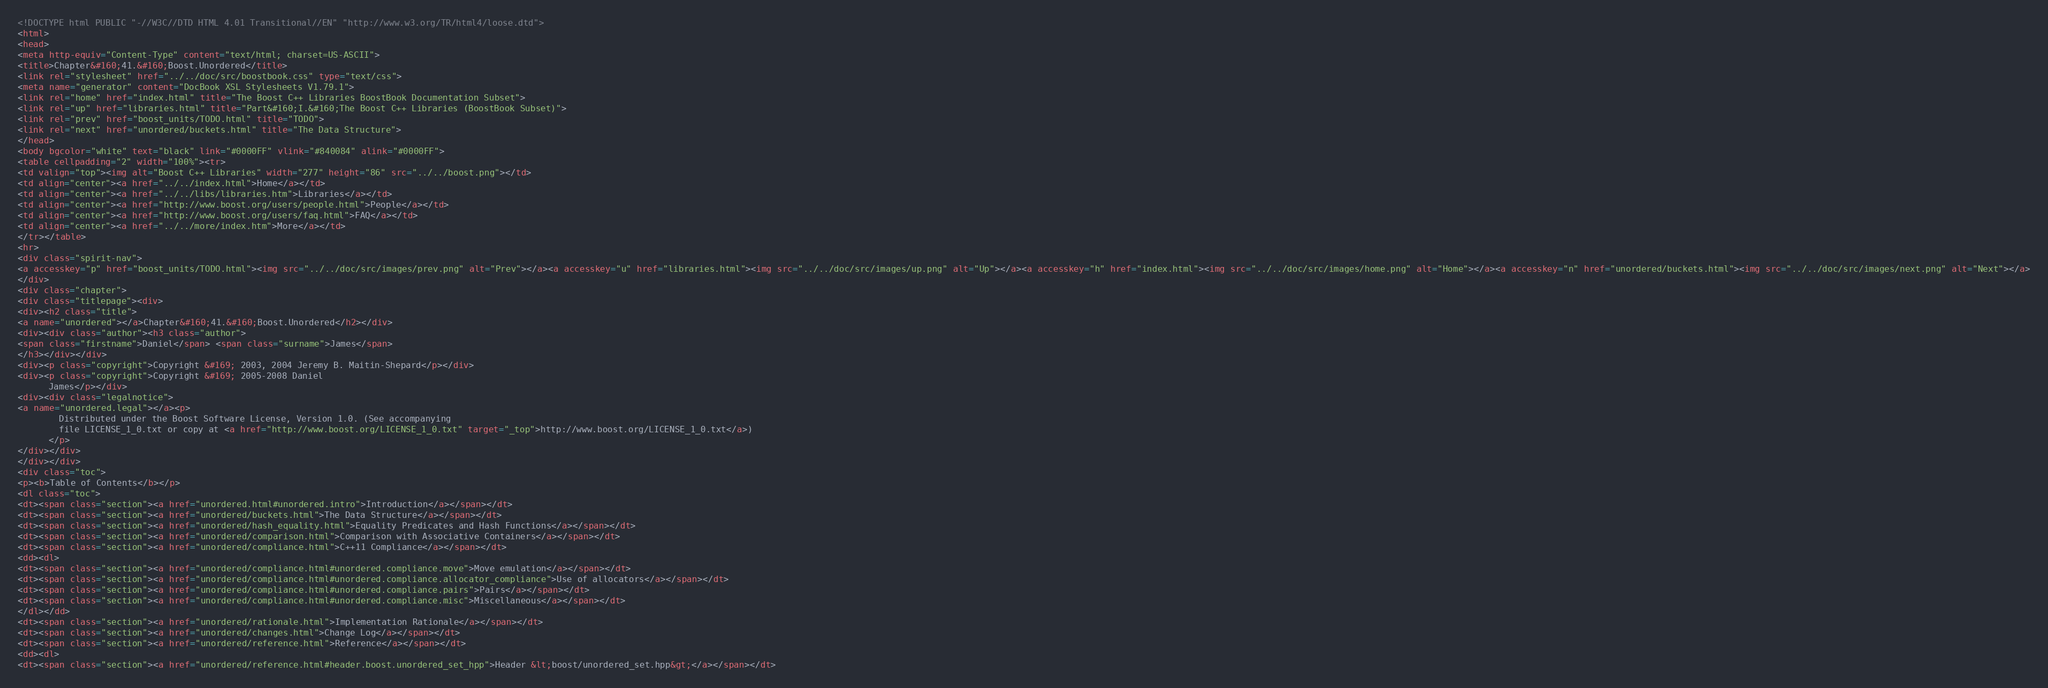Convert code to text. <code><loc_0><loc_0><loc_500><loc_500><_HTML_><!DOCTYPE html PUBLIC "-//W3C//DTD HTML 4.01 Transitional//EN" "http://www.w3.org/TR/html4/loose.dtd">
<html>
<head>
<meta http-equiv="Content-Type" content="text/html; charset=US-ASCII">
<title>Chapter&#160;41.&#160;Boost.Unordered</title>
<link rel="stylesheet" href="../../doc/src/boostbook.css" type="text/css">
<meta name="generator" content="DocBook XSL Stylesheets V1.79.1">
<link rel="home" href="index.html" title="The Boost C++ Libraries BoostBook Documentation Subset">
<link rel="up" href="libraries.html" title="Part&#160;I.&#160;The Boost C++ Libraries (BoostBook Subset)">
<link rel="prev" href="boost_units/TODO.html" title="TODO">
<link rel="next" href="unordered/buckets.html" title="The Data Structure">
</head>
<body bgcolor="white" text="black" link="#0000FF" vlink="#840084" alink="#0000FF">
<table cellpadding="2" width="100%"><tr>
<td valign="top"><img alt="Boost C++ Libraries" width="277" height="86" src="../../boost.png"></td>
<td align="center"><a href="../../index.html">Home</a></td>
<td align="center"><a href="../../libs/libraries.htm">Libraries</a></td>
<td align="center"><a href="http://www.boost.org/users/people.html">People</a></td>
<td align="center"><a href="http://www.boost.org/users/faq.html">FAQ</a></td>
<td align="center"><a href="../../more/index.htm">More</a></td>
</tr></table>
<hr>
<div class="spirit-nav">
<a accesskey="p" href="boost_units/TODO.html"><img src="../../doc/src/images/prev.png" alt="Prev"></a><a accesskey="u" href="libraries.html"><img src="../../doc/src/images/up.png" alt="Up"></a><a accesskey="h" href="index.html"><img src="../../doc/src/images/home.png" alt="Home"></a><a accesskey="n" href="unordered/buckets.html"><img src="../../doc/src/images/next.png" alt="Next"></a>
</div>
<div class="chapter">
<div class="titlepage"><div>
<div><h2 class="title">
<a name="unordered"></a>Chapter&#160;41.&#160;Boost.Unordered</h2></div>
<div><div class="author"><h3 class="author">
<span class="firstname">Daniel</span> <span class="surname">James</span>
</h3></div></div>
<div><p class="copyright">Copyright &#169; 2003, 2004 Jeremy B. Maitin-Shepard</p></div>
<div><p class="copyright">Copyright &#169; 2005-2008 Daniel
      James</p></div>
<div><div class="legalnotice">
<a name="unordered.legal"></a><p>
        Distributed under the Boost Software License, Version 1.0. (See accompanying
        file LICENSE_1_0.txt or copy at <a href="http://www.boost.org/LICENSE_1_0.txt" target="_top">http://www.boost.org/LICENSE_1_0.txt</a>)
      </p>
</div></div>
</div></div>
<div class="toc">
<p><b>Table of Contents</b></p>
<dl class="toc">
<dt><span class="section"><a href="unordered.html#unordered.intro">Introduction</a></span></dt>
<dt><span class="section"><a href="unordered/buckets.html">The Data Structure</a></span></dt>
<dt><span class="section"><a href="unordered/hash_equality.html">Equality Predicates and Hash Functions</a></span></dt>
<dt><span class="section"><a href="unordered/comparison.html">Comparison with Associative Containers</a></span></dt>
<dt><span class="section"><a href="unordered/compliance.html">C++11 Compliance</a></span></dt>
<dd><dl>
<dt><span class="section"><a href="unordered/compliance.html#unordered.compliance.move">Move emulation</a></span></dt>
<dt><span class="section"><a href="unordered/compliance.html#unordered.compliance.allocator_compliance">Use of allocators</a></span></dt>
<dt><span class="section"><a href="unordered/compliance.html#unordered.compliance.pairs">Pairs</a></span></dt>
<dt><span class="section"><a href="unordered/compliance.html#unordered.compliance.misc">Miscellaneous</a></span></dt>
</dl></dd>
<dt><span class="section"><a href="unordered/rationale.html">Implementation Rationale</a></span></dt>
<dt><span class="section"><a href="unordered/changes.html">Change Log</a></span></dt>
<dt><span class="section"><a href="unordered/reference.html">Reference</a></span></dt>
<dd><dl>
<dt><span class="section"><a href="unordered/reference.html#header.boost.unordered_set_hpp">Header &lt;boost/unordered_set.hpp&gt;</a></span></dt></code> 